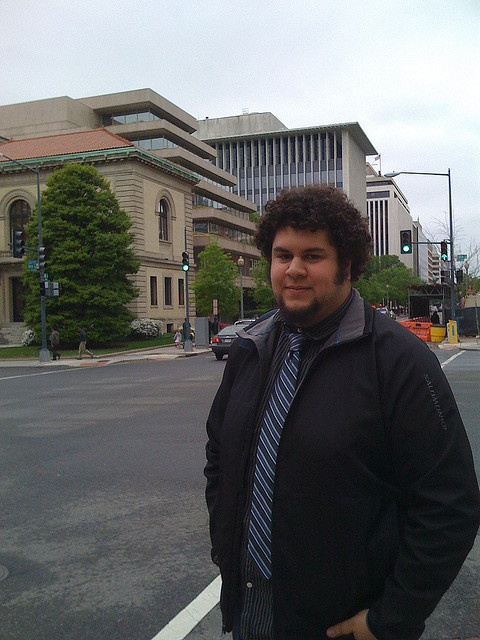Describe the objects in this image and their specific colors. I can see people in lightgray, black, maroon, and gray tones, tie in lightgray, black, and gray tones, car in lightgray, black, gray, and maroon tones, people in lightgray, black, gray, and darkgreen tones, and traffic light in lightgray, black, gray, and purple tones in this image. 